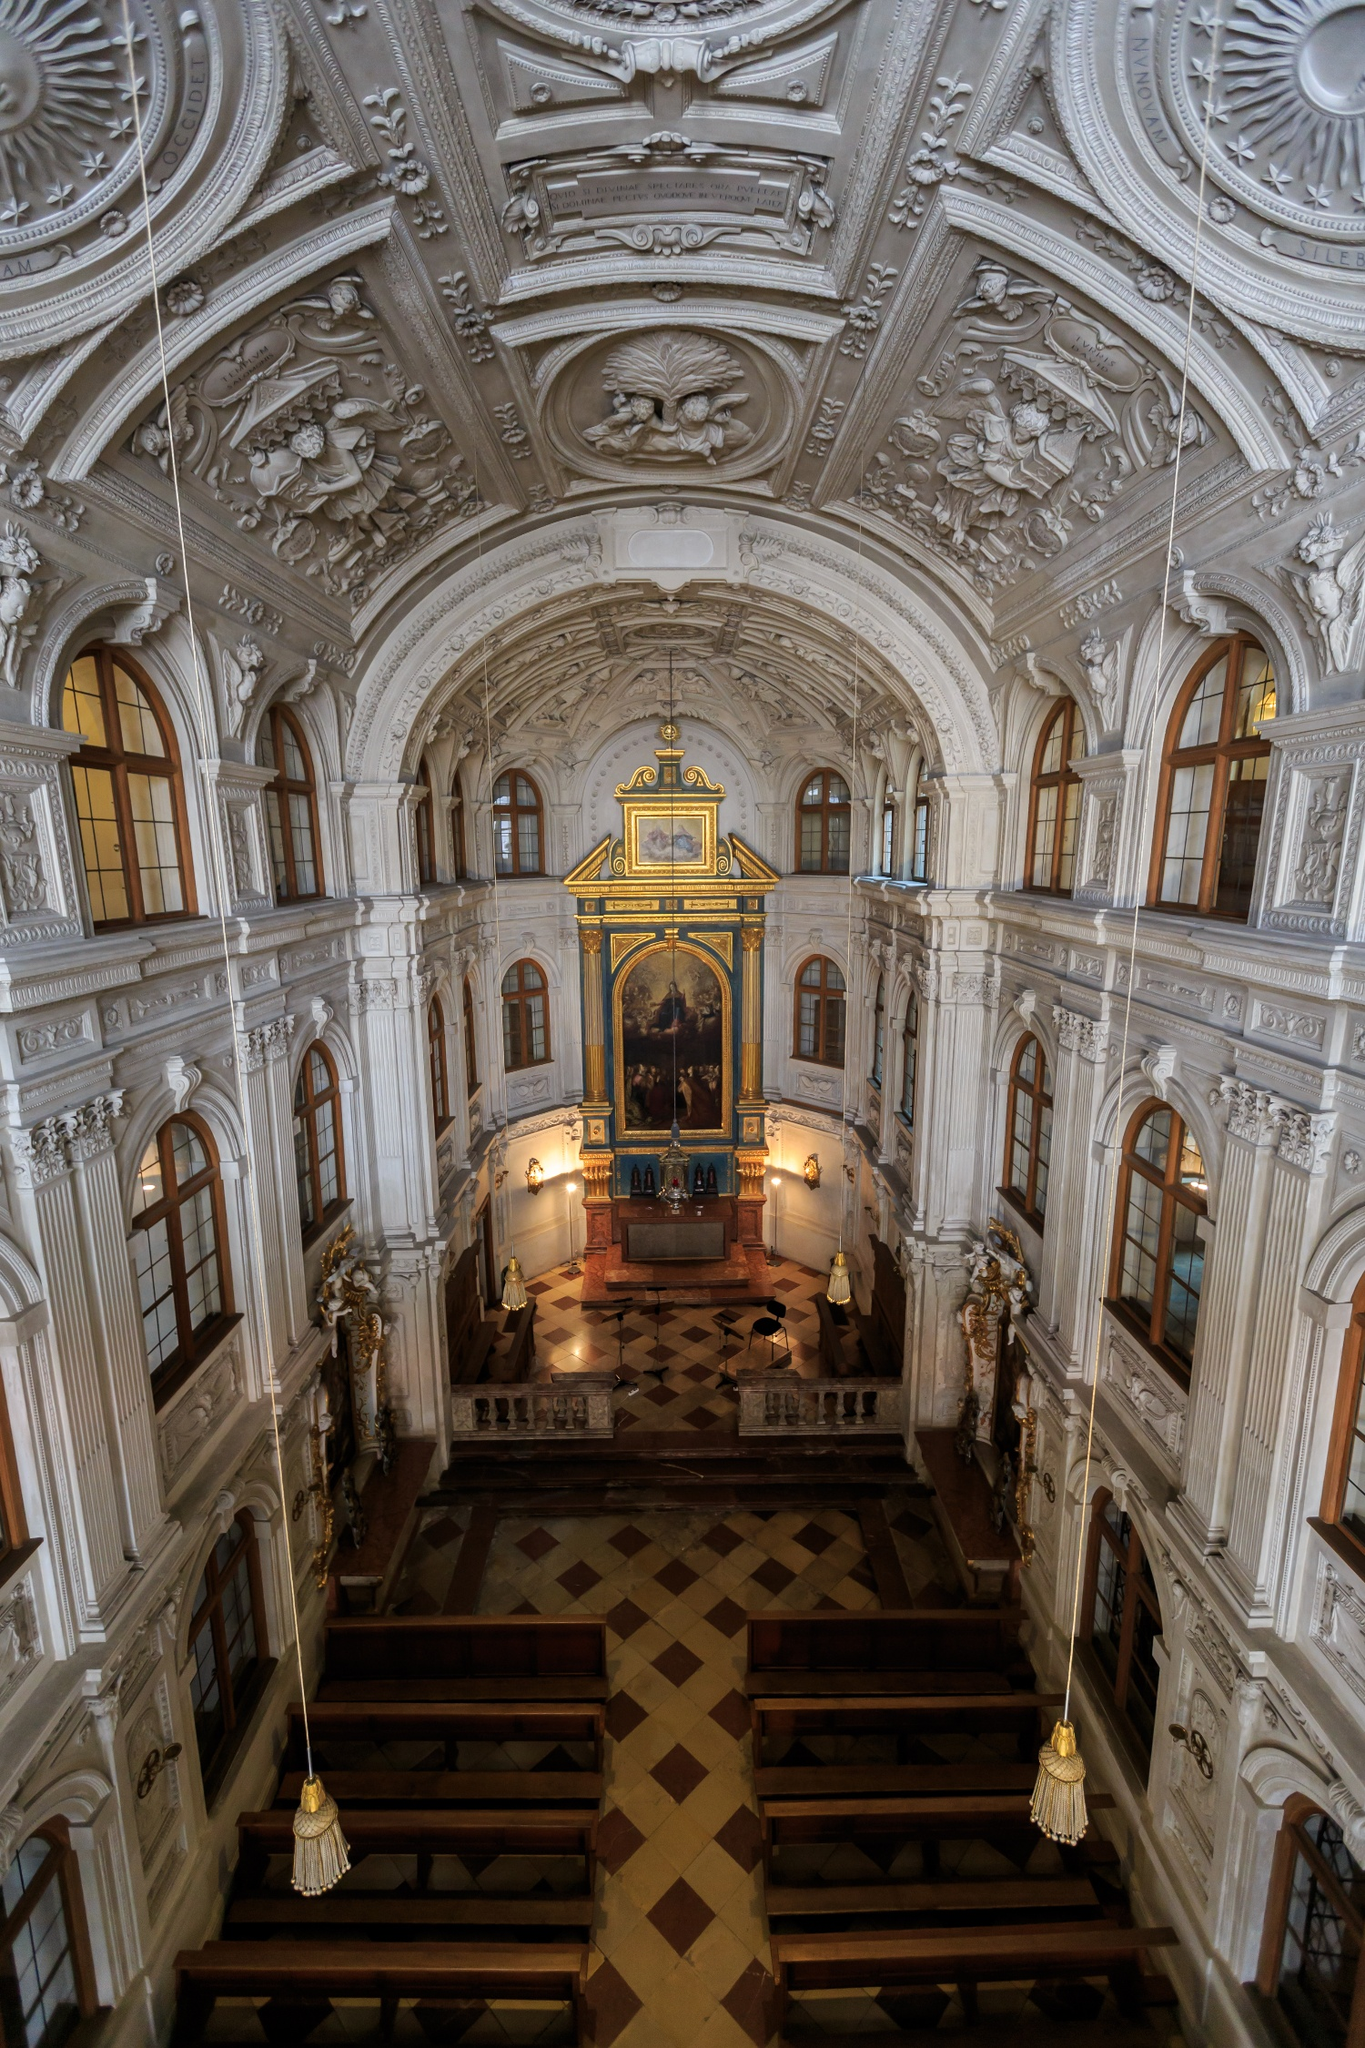What must it have felt like to attend a service here during the 18th century? Attending a service at the Hofkirche during the 18th century must have been a profoundly awe-inspiring experience. Worshippers would be enveloped in an atmosphere of grandeur and devotion, surrounded by ornately decorated walls, shimmering gold accents, and the solemn beauty of the Virgin Mary and Jesus painting. The scent of incense would pervade the air as the harmonious sounds of an organ filled the vast space. The faithful likely felt a deep sense of connection to the divine amid the exquisite artistry and architectural splendor, cementing their spiritual and cultural identity within this sacred place. 